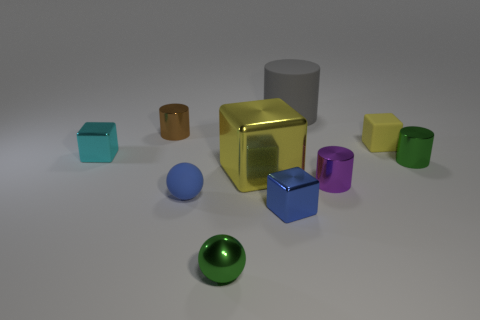How many cylinders are there?
Provide a short and direct response. 4. How many green metal cylinders have the same size as the purple metallic thing?
Your answer should be very brief. 1. What material is the small yellow thing?
Provide a succinct answer. Rubber. There is a big shiny cube; is it the same color as the tiny rubber object on the right side of the tiny metallic sphere?
Your answer should be very brief. Yes. There is a object that is to the left of the blue sphere and right of the tiny cyan block; what is its size?
Ensure brevity in your answer.  Small. What shape is the large yellow object that is the same material as the green sphere?
Your answer should be very brief. Cube. Do the tiny purple thing and the cylinder that is to the left of the gray cylinder have the same material?
Give a very brief answer. Yes. There is a metal block that is on the right side of the big cube; are there any small blocks that are behind it?
Give a very brief answer. Yes. What is the material of the small yellow object that is the same shape as the tiny cyan object?
Your response must be concise. Rubber. There is a green object behind the green shiny sphere; how many yellow things are behind it?
Ensure brevity in your answer.  1. 